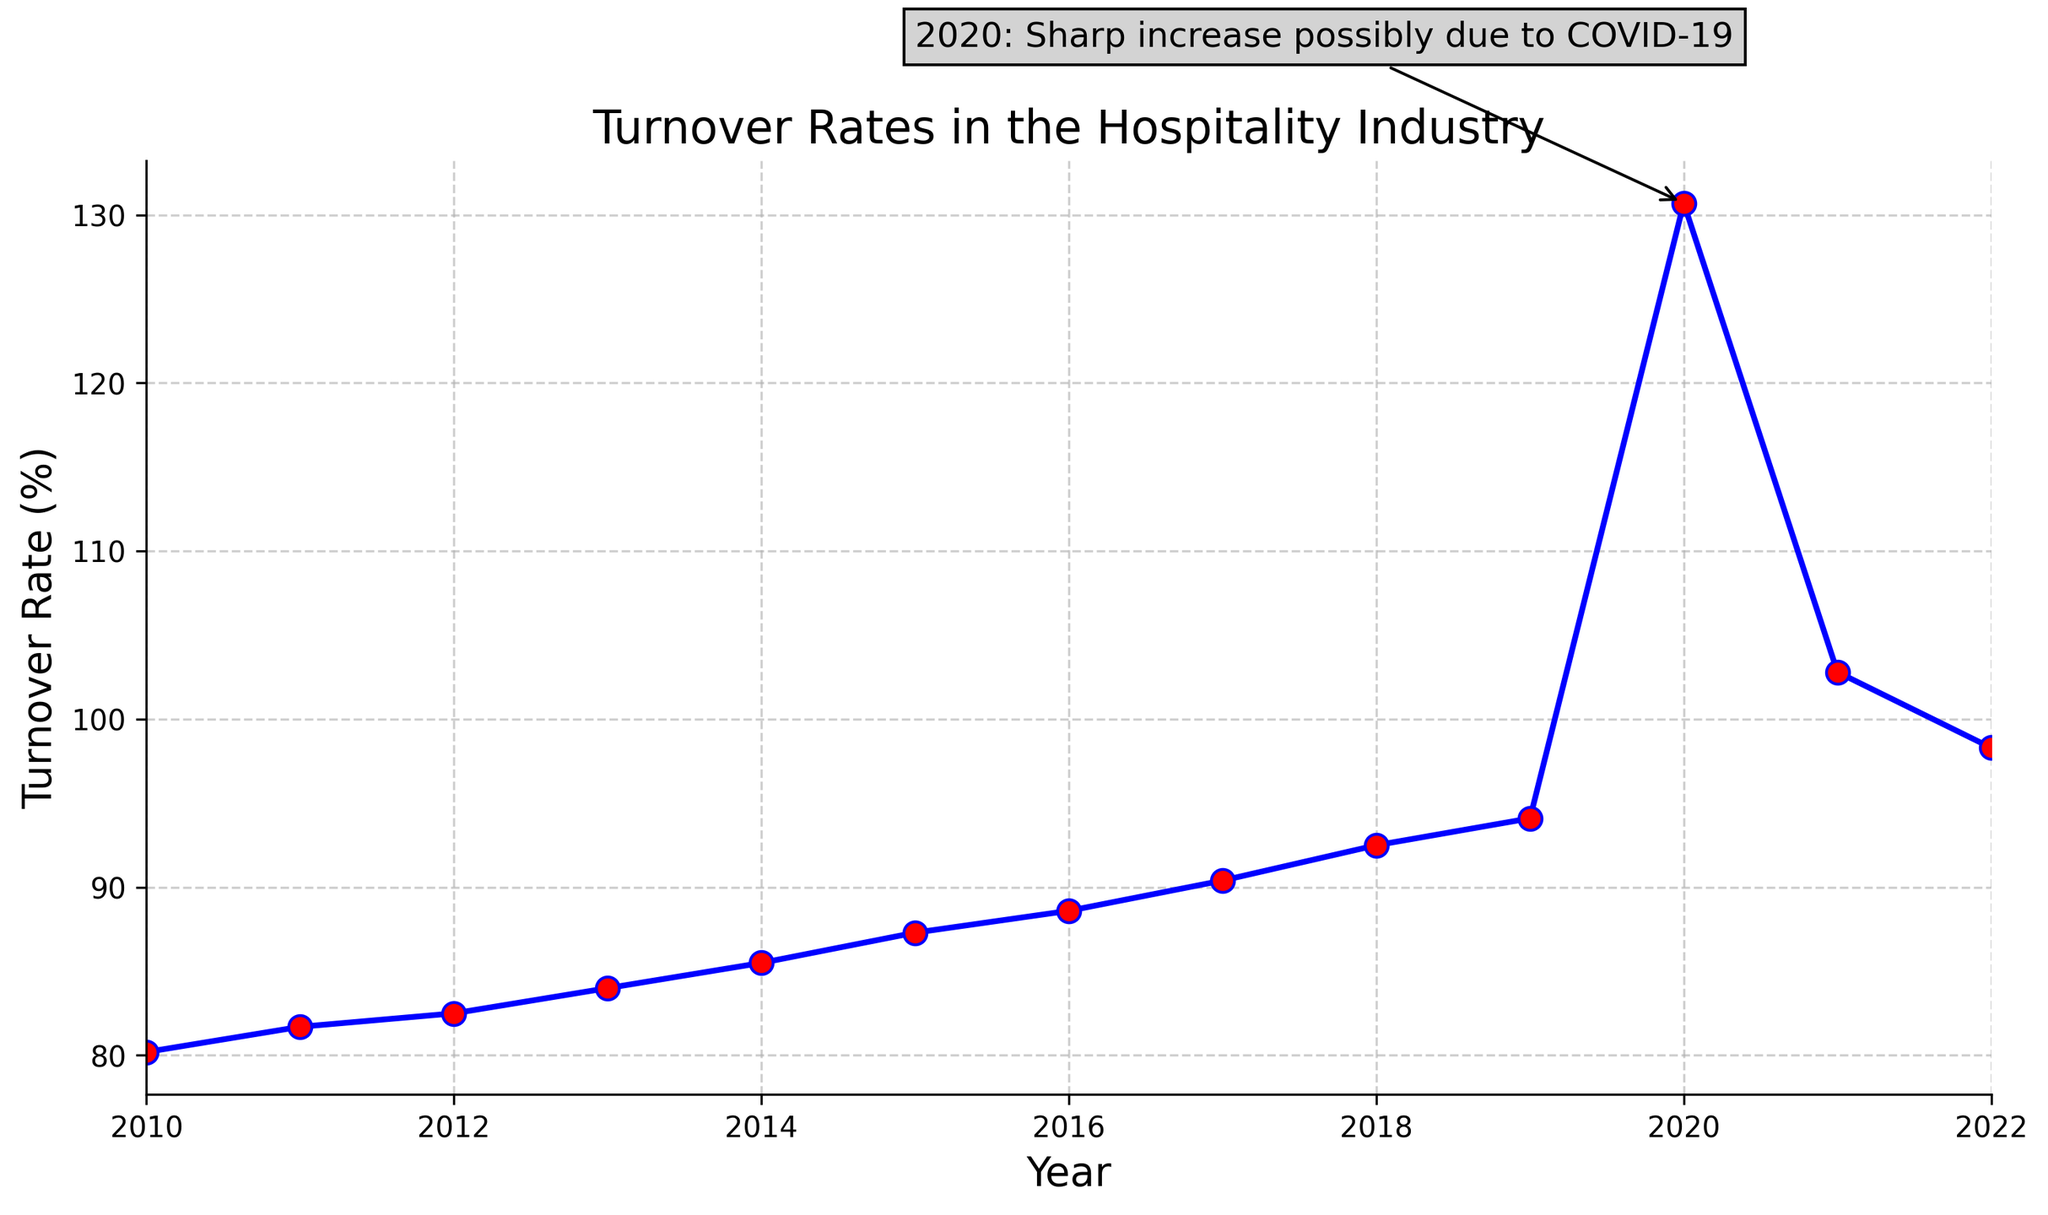What year had the highest turnover rate? The highest turnover rate is marked by both the visual spike and the annotation mentioning the sharp increase in 2020. The turnover rate in that year is visibly the highest at 130.7%.
Answer: 2020 How did the turnover rate change from 2019 to 2020? To find this, observe the turnover rates for both years: In 2019, the turnover rate was 94.1%, and in 2020, it increased to 130.7%. Calculate the difference: 130.7% - 94.1% = 36.6%.
Answer: Increased by 36.6% What is the average turnover rate from 2010 to 2019? Sum the turnover rates from 2010 to 2019: (80.2 + 81.7 + 82.5 + 84.0 + 85.5 + 87.3 + 88.6 + 90.4 + 92.5 + 94.1) = 867.8. Count the years: 10. Divide the total by the number of years: 867.8 / 10 = 86.78%.
Answer: 86.78% In which year did the turnover rate begin to decline after the peak in 2020? The turnover rate peaked in 2020 at 130.7%. It then starts to decline in 2021, as evidenced by the drop to 102.8%.
Answer: 2021 How much did the turnover rate change from 2021 to 2022? Compare the turnover rates of the two years: In 2021, it was 102.8%, and in 2022, it was 98.3%, resulting in a change of 102.8% - 98.3% = 4.5%.
Answer: Decreased by 4.5% What was the trend of the turnover rate from 2010 to 2019? Observing the turnover rates from 2010 to 2019, the data consistently shows an upward trend each year, starting from 80.2% in 2010 and rising each year up to 94.1% in 2019.
Answer: Upward trend Which year had a higher turnover rate, 2013 or 2015, and by how much? To compare the turnover rates, look at the values for 2013 and 2015: 2013 had a turnover rate of 84.0% and 2015 had 87.3%. The difference is 87.3% - 84.0% = 3.3%.
Answer: 2015 by 3.3% Was the turnover rate in 2021 higher or lower than in 2018? Compare the turnover rates: 2021 had a turnover rate of 102.8% and 2018 had 92.5%. 102.8% is higher than 92.5%.
Answer: Higher How did the turnover rate in 2014 compare to 2016? To compare the turnover rates, check the values: 2014 had a rate of 85.5% and 2016 had 88.6%. 88.6% is greater than 85.5%.
Answer: 2016 was higher What visual annotation is noted on the plot and why? The annotation on the plot points to the year 2020, stating "2020: Sharp increase possibly due to COVID-19". This highlights the significant jump in turnover rate for that year.
Answer: Sharp increase in 2020 due to COVID-19 